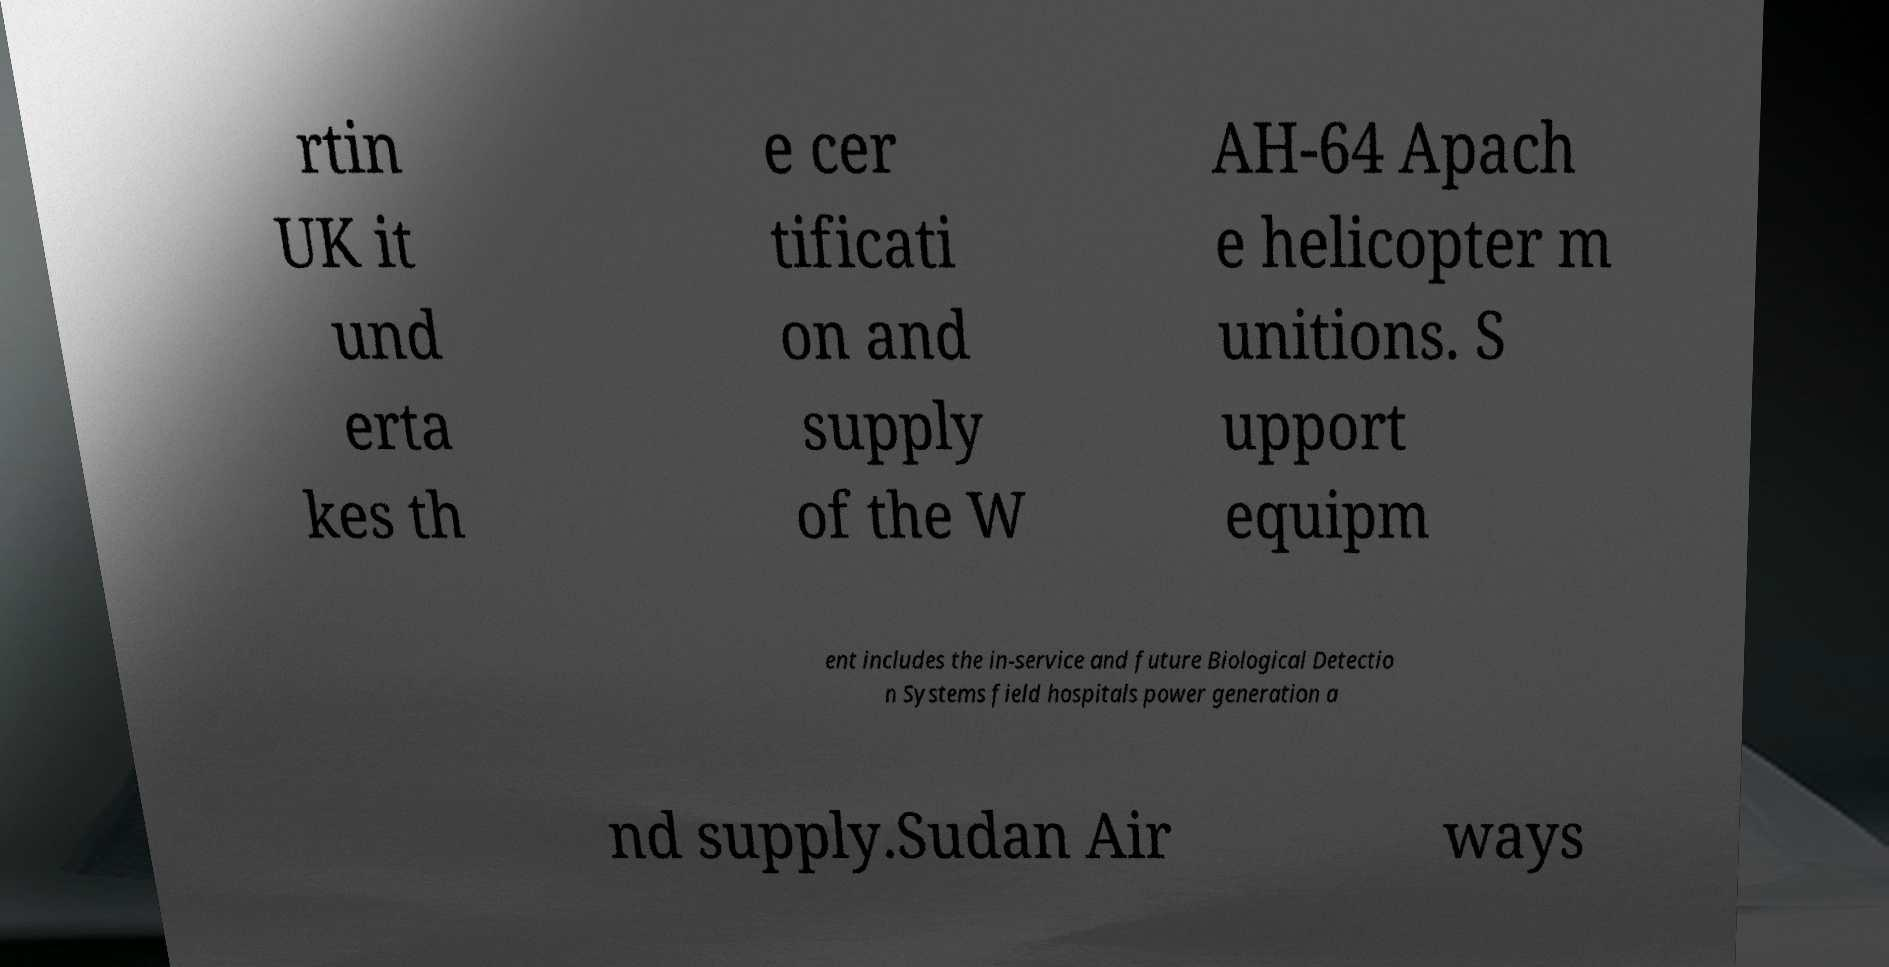For documentation purposes, I need the text within this image transcribed. Could you provide that? rtin UK it und erta kes th e cer tificati on and supply of the W AH-64 Apach e helicopter m unitions. S upport equipm ent includes the in-service and future Biological Detectio n Systems field hospitals power generation a nd supply.Sudan Air ways 